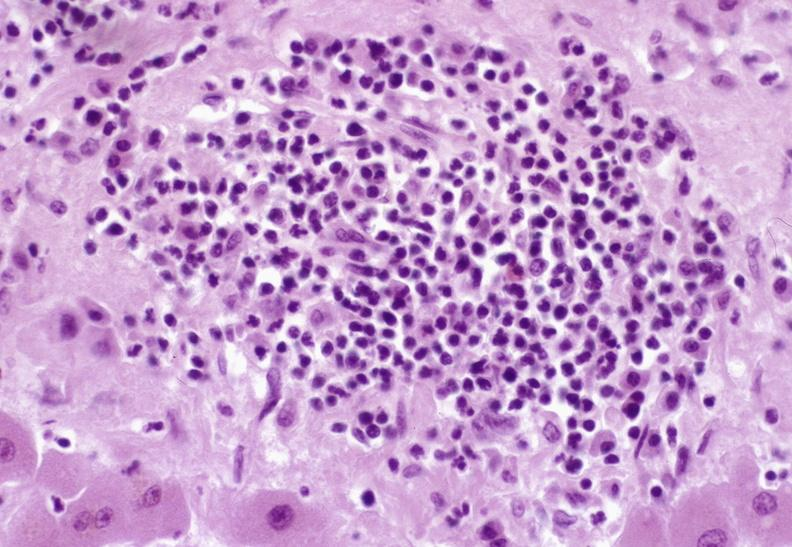what is present?
Answer the question using a single word or phrase. Liver 